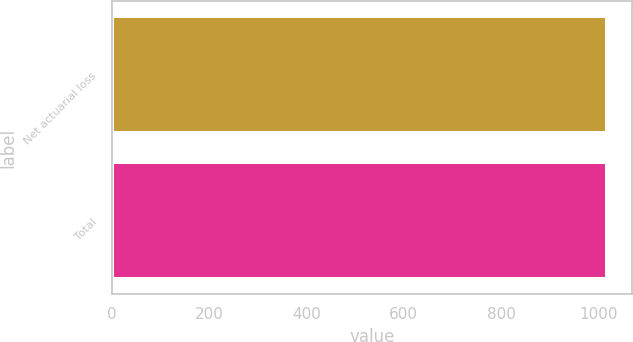Convert chart. <chart><loc_0><loc_0><loc_500><loc_500><bar_chart><fcel>Net actuarial loss<fcel>Total<nl><fcel>1018<fcel>1018.1<nl></chart> 